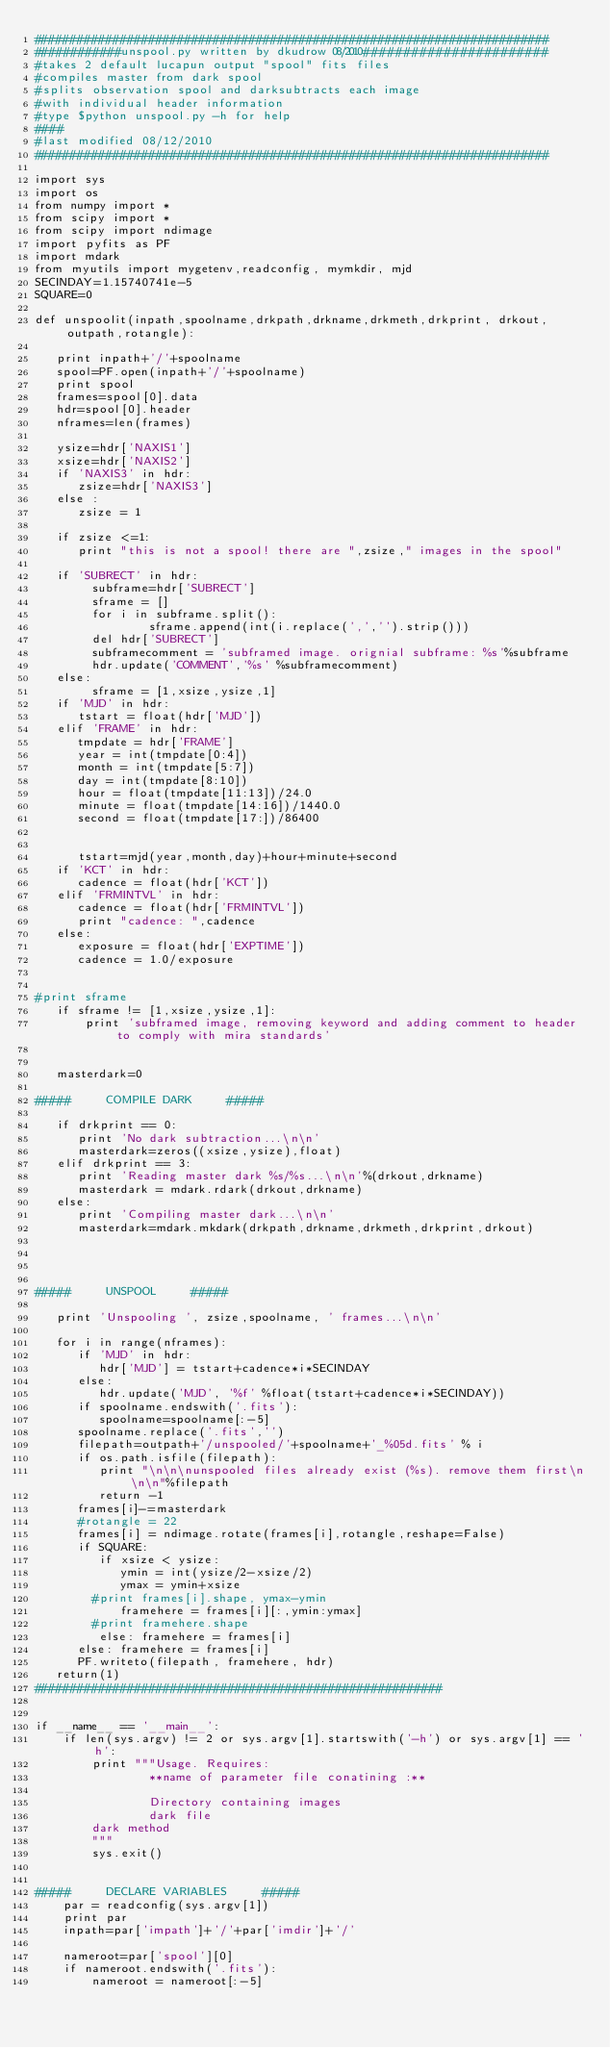Convert code to text. <code><loc_0><loc_0><loc_500><loc_500><_Python_>########################################################################
############unspool.py written by dkudrow 08/2010#######################
#takes 2 default lucapun output "spool" fits files
#compiles master from dark spool
#splits observation spool and darksubtracts each image
#with individual header information
#type $python unspool.py -h for help
####
#last modified 08/12/2010
########################################################################

import sys
import os
from numpy import *
from scipy import *
from scipy import ndimage
import pyfits as PF
import mdark
from myutils import mygetenv,readconfig, mymkdir, mjd
SECINDAY=1.15740741e-5
SQUARE=0

def unspoolit(inpath,spoolname,drkpath,drkname,drkmeth,drkprint, drkout,outpath,rotangle):

   print inpath+'/'+spoolname
   spool=PF.open(inpath+'/'+spoolname)
   print spool
   frames=spool[0].data
   hdr=spool[0].header
   nframes=len(frames)

   ysize=hdr['NAXIS1']
   xsize=hdr['NAXIS2']
   if 'NAXIS3' in hdr:
      zsize=hdr['NAXIS3']
   else :
      zsize = 1

   if zsize <=1:
      print "this is not a spool! there are ",zsize," images in the spool" 

   if 'SUBRECT' in hdr:
        subframe=hdr['SUBRECT']
        sframe = []
        for i in subframe.split():
                sframe.append(int(i.replace(',','').strip()))
        del hdr['SUBRECT']
        subframecomment = 'subframed image. orignial subframe: %s'%subframe
        hdr.update('COMMENT','%s' %subframecomment)
   else:
        sframe = [1,xsize,ysize,1]
   if 'MJD' in hdr:
      tstart = float(hdr['MJD'])
   elif 'FRAME' in hdr:
      tmpdate = hdr['FRAME']
      year = int(tmpdate[0:4])
      month = int(tmpdate[5:7])
      day = int(tmpdate[8:10])    
      hour = float(tmpdate[11:13])/24.0
      minute = float(tmpdate[14:16])/1440.0
      second = float(tmpdate[17:])/86400
      
        
      tstart=mjd(year,month,day)+hour+minute+second
   if 'KCT' in hdr:
      cadence = float(hdr['KCT'])
   elif 'FRMINTVL' in hdr:
      cadence = float(hdr['FRMINTVL'])
      print "cadence: ",cadence
   else: 
      exposure = float(hdr['EXPTIME'])
      cadence = 1.0/exposure
      

#print sframe 
   if sframe != [1,xsize,ysize,1]:
       print 'subframed image, removing keyword and adding comment to header to comply with mira standards'


   masterdark=0

#####     COMPILE DARK     #####

   if drkprint == 0:
      print 'No dark subtraction...\n\n'
      masterdark=zeros((xsize,ysize),float)
   elif drkprint == 3:
      print 'Reading master dark %s/%s...\n\n'%(drkout,drkname)
      masterdark = mdark.rdark(drkout,drkname)
   else:
      print 'Compiling master dark...\n\n'
      masterdark=mdark.mkdark(drkpath,drkname,drkmeth,drkprint,drkout)




#####     UNSPOOL     #####

   print 'Unspooling ', zsize,spoolname, ' frames...\n\n'

   for i in range(nframes):
      if 'MJD' in hdr:
         hdr['MJD'] = tstart+cadence*i*SECINDAY
      else:
         hdr.update('MJD', '%f' %float(tstart+cadence*i*SECINDAY))
      if spoolname.endswith('.fits'):
         spoolname=spoolname[:-5]
      spoolname.replace('.fits','')
      filepath=outpath+'/unspooled/'+spoolname+'_%05d.fits' % i
      if os.path.isfile(filepath):
         print "\n\n\nunspooled files already exist (%s). remove them first\n\n\n"%filepath
         return -1
      frames[i]-=masterdark
      #rotangle = 22
      frames[i] = ndimage.rotate(frames[i],rotangle,reshape=False)
      if SQUARE:
         if xsize < ysize:
            ymin = int(ysize/2-xsize/2)
            ymax = ymin+xsize
		#print frames[i].shape, ymax-ymin   
            framehere = frames[i][:,ymin:ymax]
		#print framehere.shape
         else: framehere = frames[i]
      else: framehere = frames[i]
      PF.writeto(filepath, framehere, hdr)
   return(1)
#########################################################


if __name__ == '__main__':
    if len(sys.argv) != 2 or sys.argv[1].startswith('-h') or sys.argv[1] == 'h':
        print """Usage. Requires: 
                **name of parameter file conatining :**
                
                Directory containing images
            	dark file
		dark method
		"""
    	sys.exit()


#####     DECLARE VARIABLES     #####
    par = readconfig(sys.argv[1])
    print par
    inpath=par['impath']+'/'+par['imdir']+'/'
    
    nameroot=par['spool'][0]
    if nameroot.endswith('.fits'):
        nameroot = nameroot[:-5]
</code> 